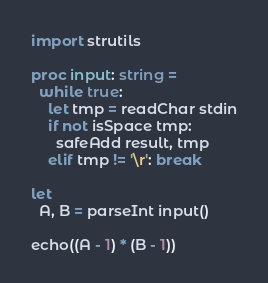<code> <loc_0><loc_0><loc_500><loc_500><_Nim_>import strutils

proc input: string =
  while true:
    let tmp = readChar stdin
    if not isSpace tmp:
      safeAdd result, tmp
    elif tmp != '\r': break

let
  A, B = parseInt input()

echo((A - 1) * (B - 1))
</code> 